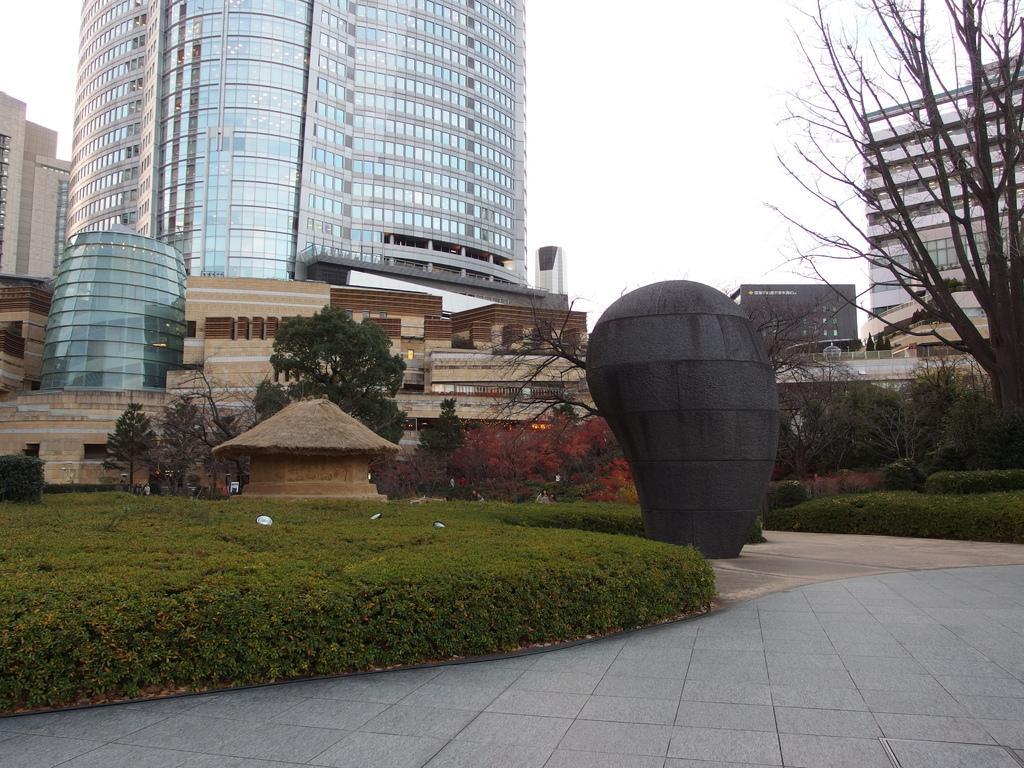What type of structure is the main focus of the image? There is a skyscraper in the image. What other types of structures can be seen in the image? There are buildings in the image. What natural elements are present in the image? There are trees, plants, grass, and the sky visible in the image. Can you describe the sky in the image? The sky is visible in the image, and there are clouds present. What else can be seen in the image besides the skyscraper, buildings, and natural elements? There is a hut and other objects in the image. What condition is the kitty in while sitting on the expert's lap in the image? There is no kitty or expert present in the image. 